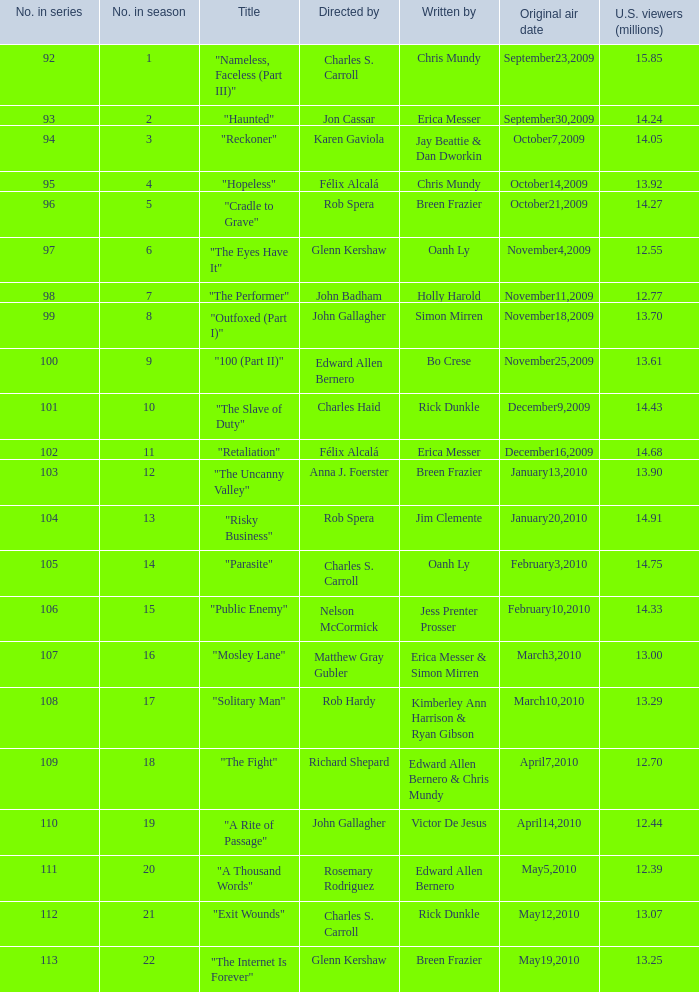Who authored episode 109 in the series? Edward Allen Bernero & Chris Mundy. 